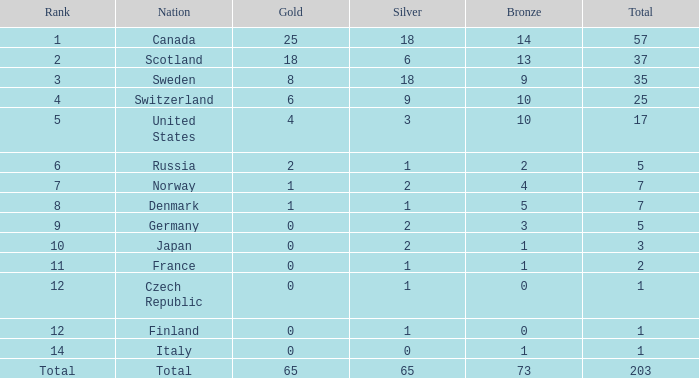What is the complete sum of medals when there are 18 gold medals? 37.0. 